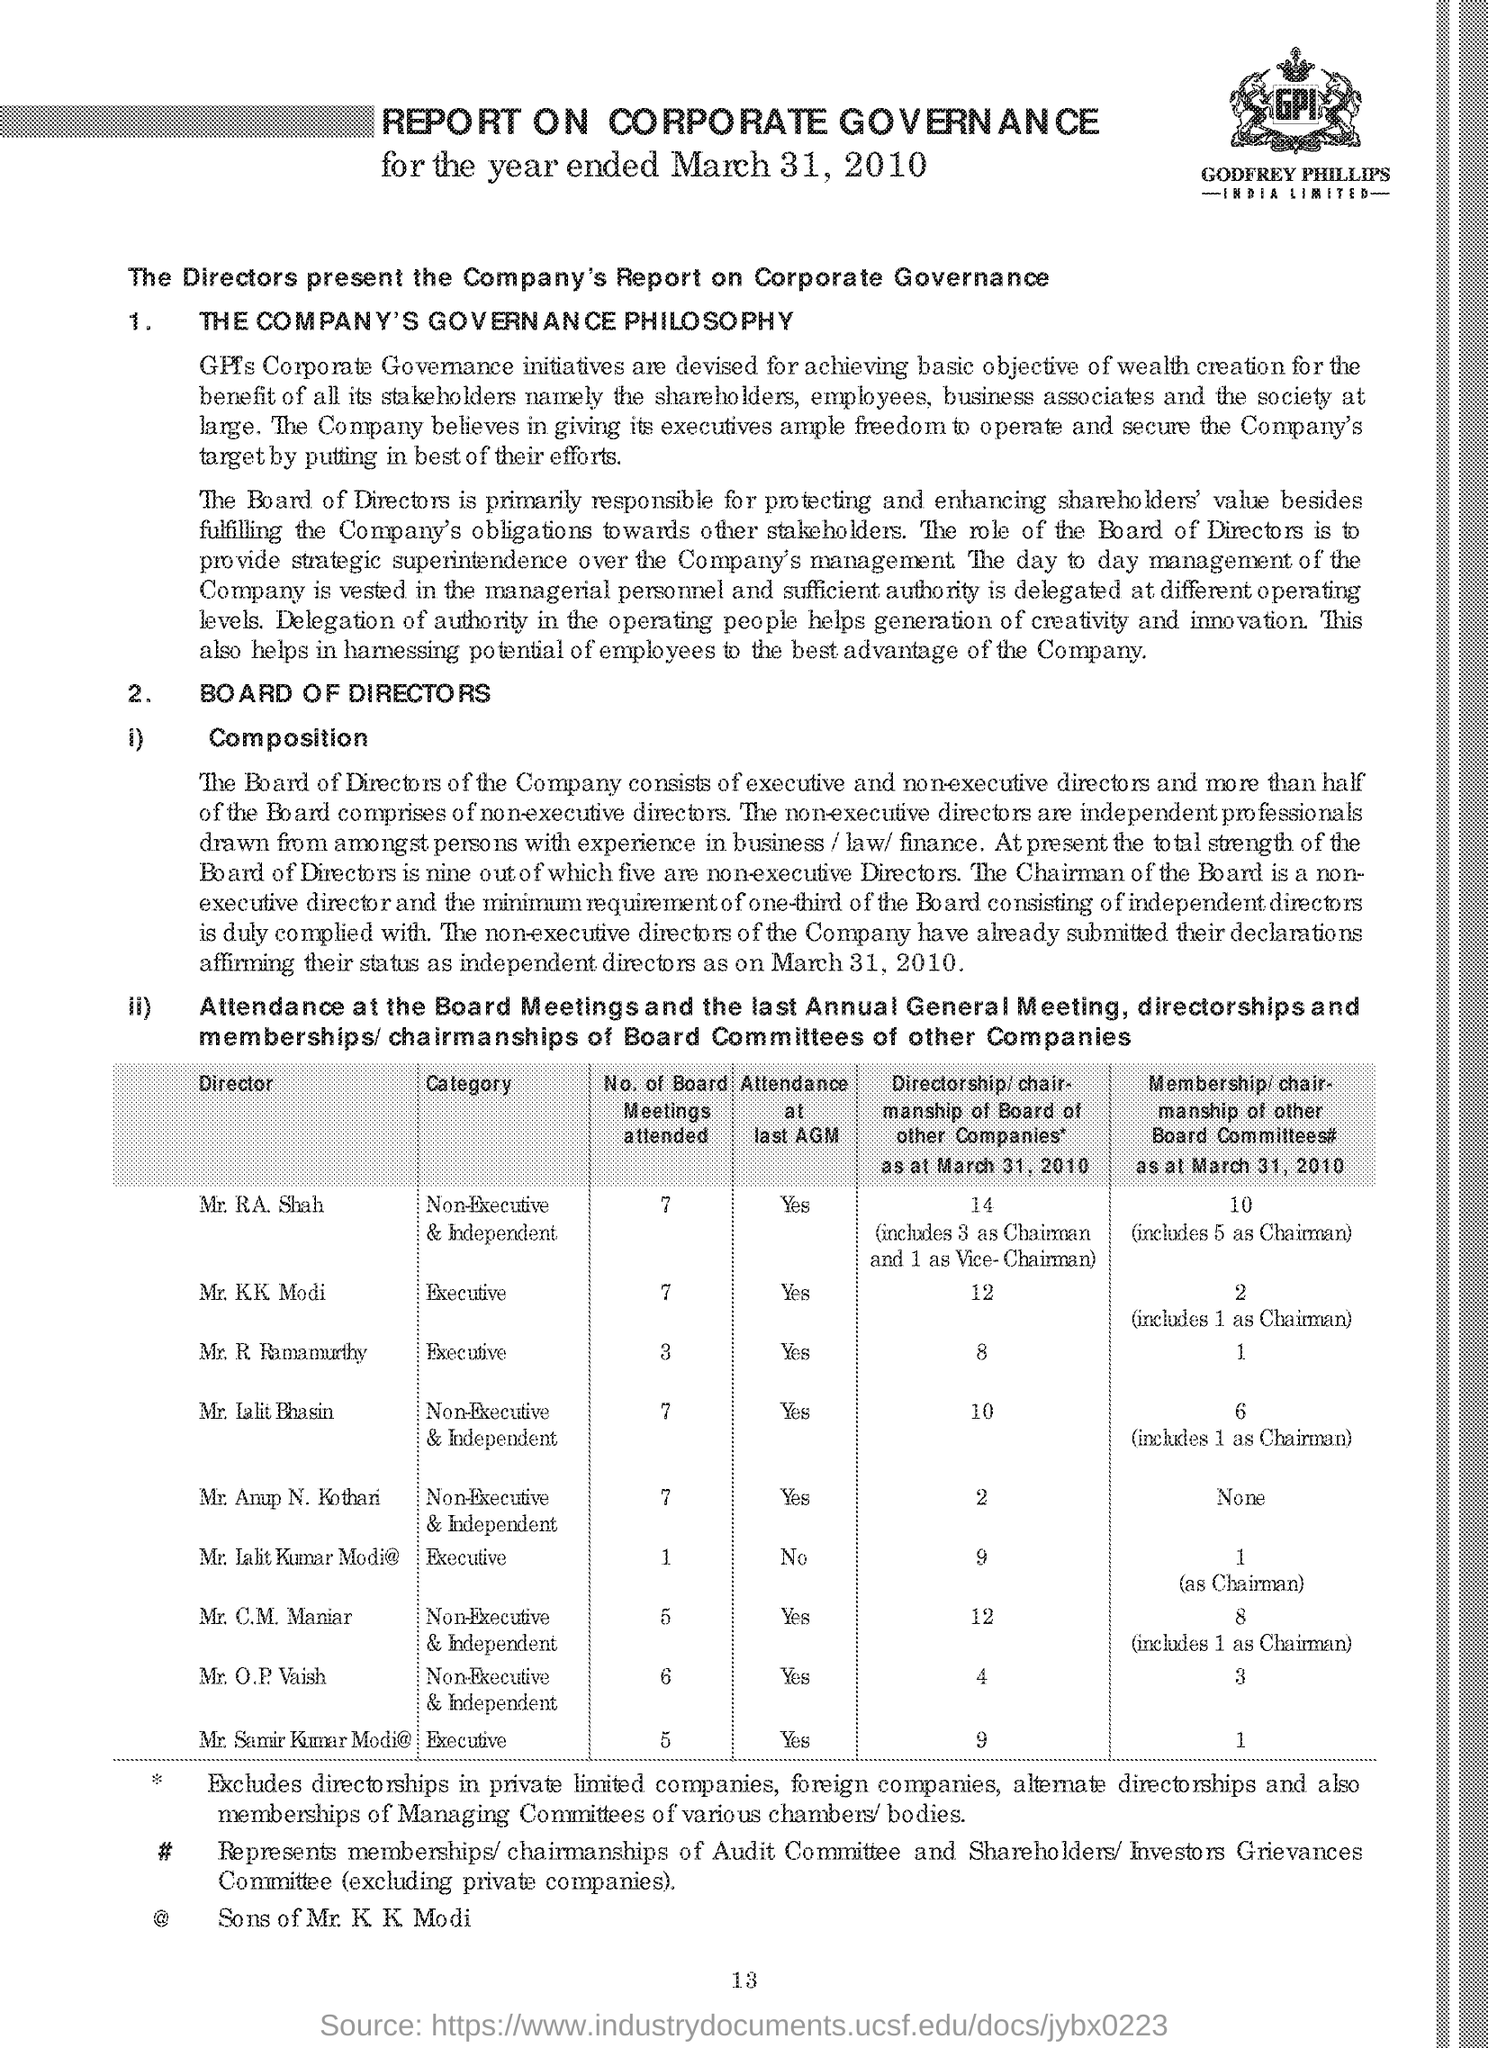The directors present the company's report on what
Your answer should be compact. Corporate Governance. 